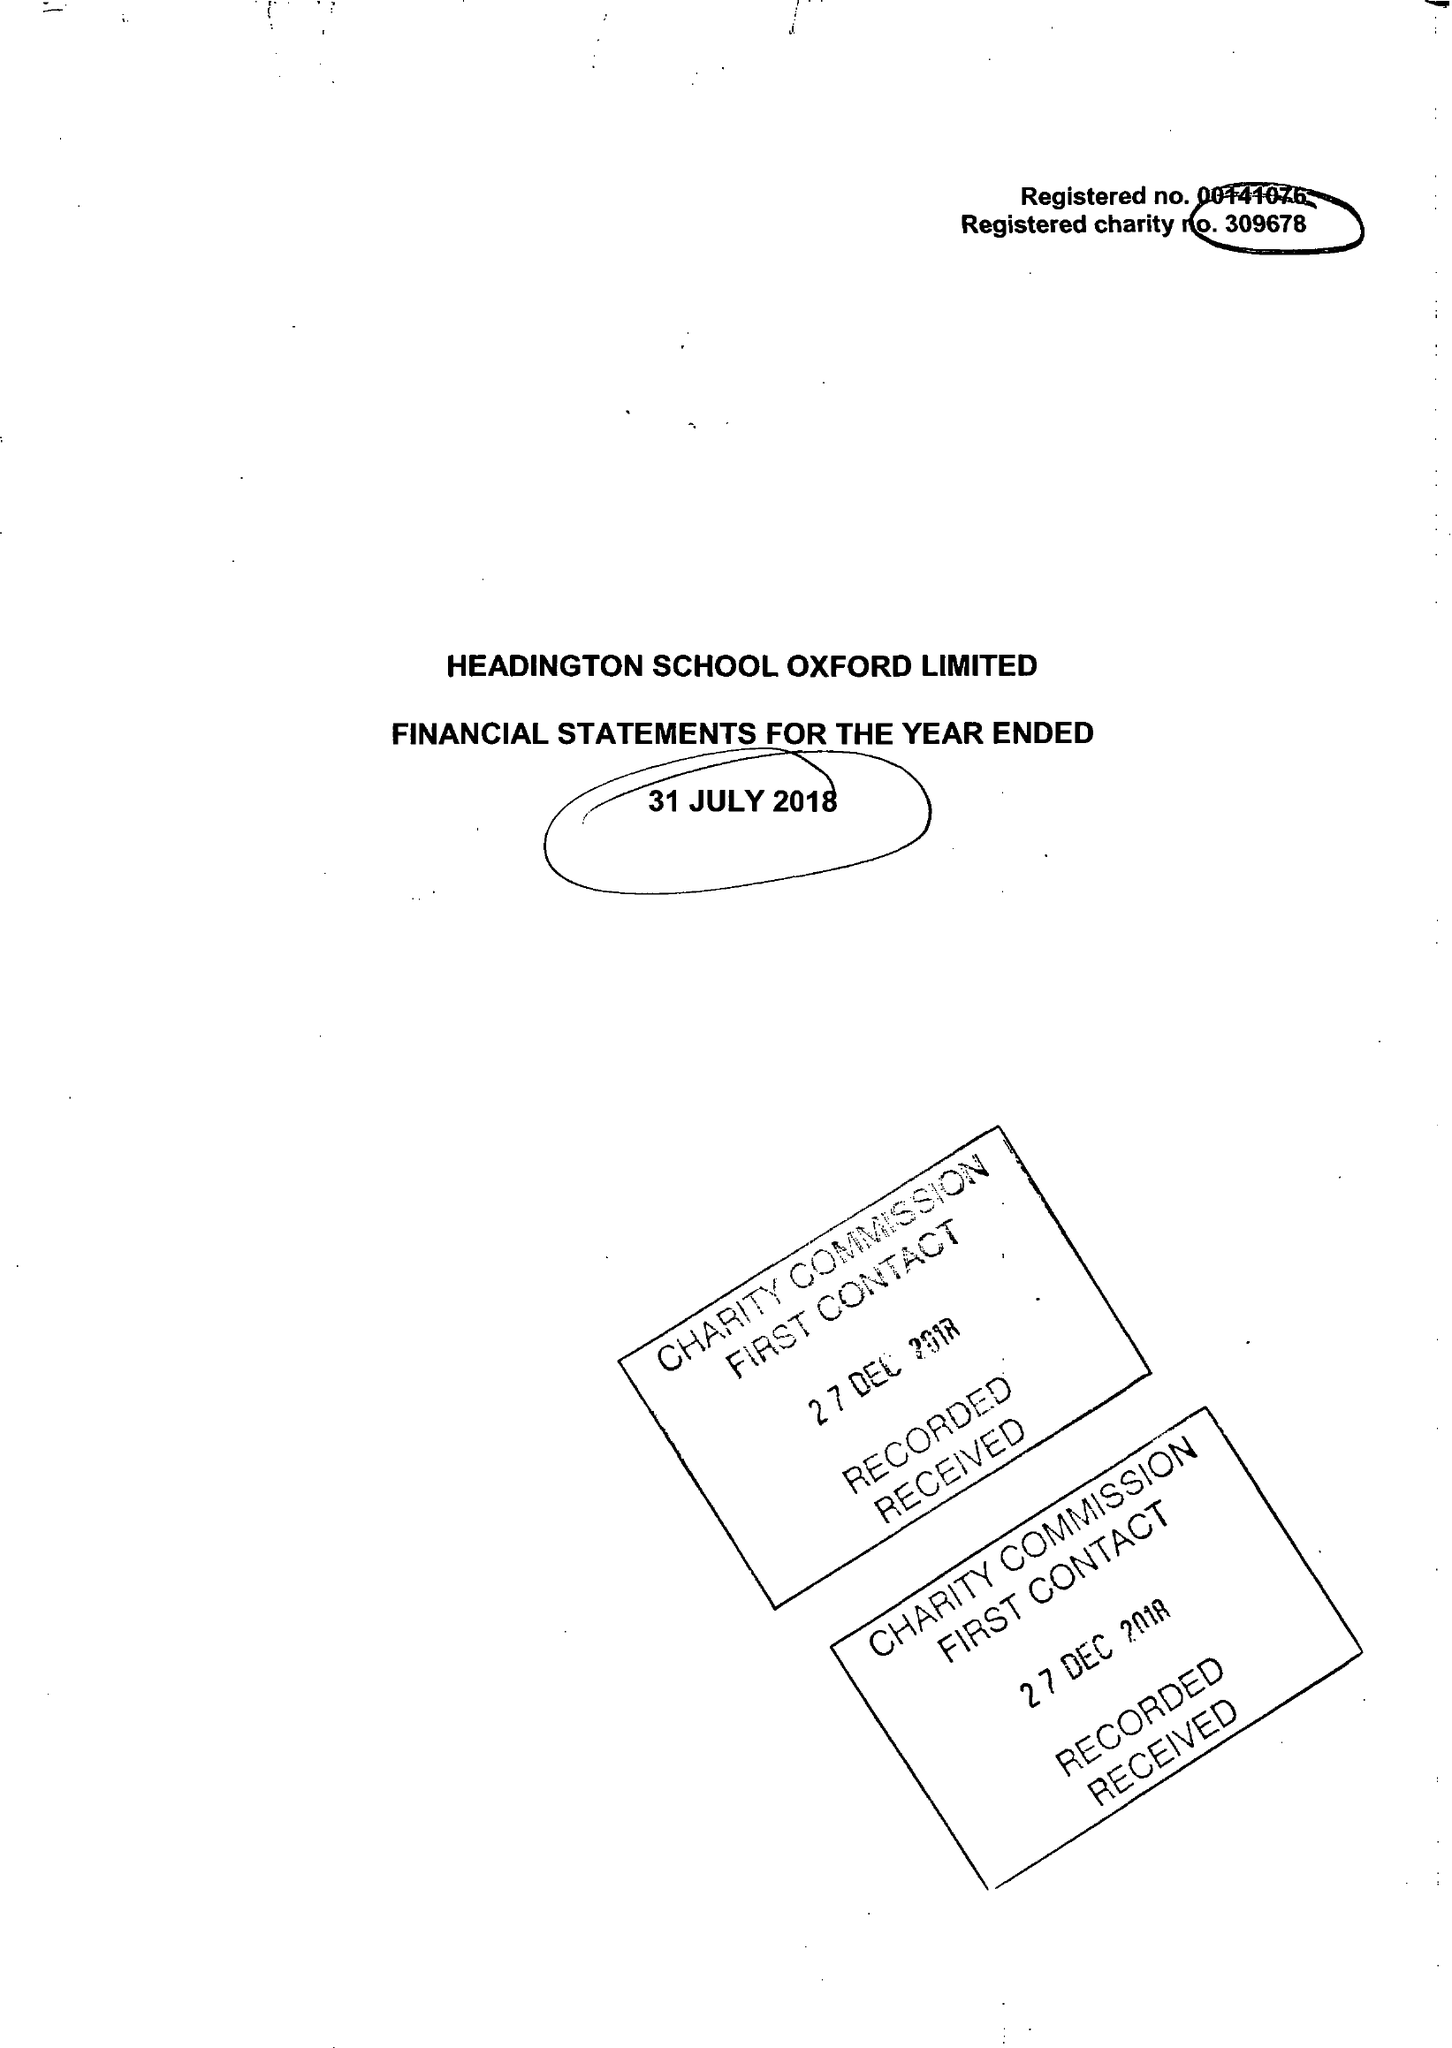What is the value for the spending_annually_in_british_pounds?
Answer the question using a single word or phrase. 19997475.00 